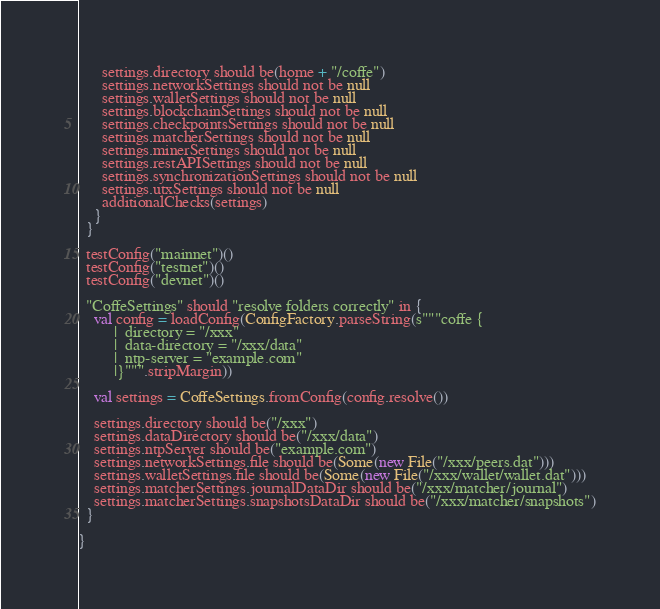<code> <loc_0><loc_0><loc_500><loc_500><_Scala_>
      settings.directory should be(home + "/coffe")
      settings.networkSettings should not be null
      settings.walletSettings should not be null
      settings.blockchainSettings should not be null
      settings.checkpointsSettings should not be null
      settings.matcherSettings should not be null
      settings.minerSettings should not be null
      settings.restAPISettings should not be null
      settings.synchronizationSettings should not be null
      settings.utxSettings should not be null
      additionalChecks(settings)
    }
  }

  testConfig("mainnet")()
  testConfig("testnet")()
  testConfig("devnet")()

  "CoffeSettings" should "resolve folders correctly" in {
    val config = loadConfig(ConfigFactory.parseString(s"""coffe {
         |  directory = "/xxx"
         |  data-directory = "/xxx/data"
         |  ntp-server = "example.com"
         |}""".stripMargin))

    val settings = CoffeSettings.fromConfig(config.resolve())

    settings.directory should be("/xxx")
    settings.dataDirectory should be("/xxx/data")
    settings.ntpServer should be("example.com")
    settings.networkSettings.file should be(Some(new File("/xxx/peers.dat")))
    settings.walletSettings.file should be(Some(new File("/xxx/wallet/wallet.dat")))
    settings.matcherSettings.journalDataDir should be("/xxx/matcher/journal")
    settings.matcherSettings.snapshotsDataDir should be("/xxx/matcher/snapshots")
  }

}
</code> 